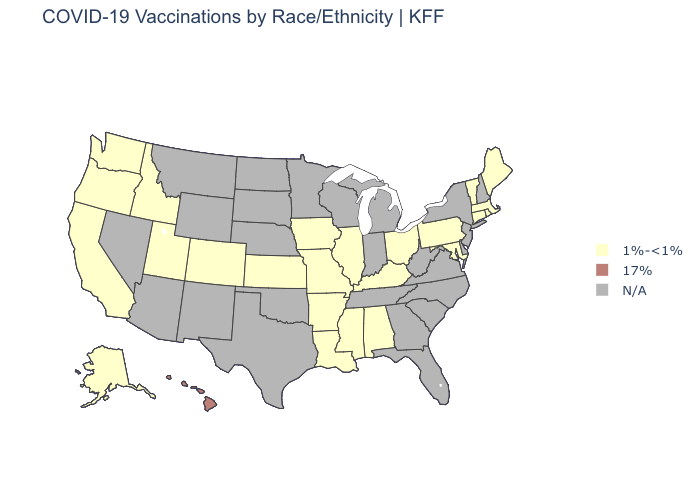Among the states that border Florida , which have the highest value?
Be succinct. Alabama. Is the legend a continuous bar?
Short answer required. No. Name the states that have a value in the range N/A?
Concise answer only. Arizona, Delaware, Florida, Georgia, Indiana, Michigan, Minnesota, Montana, Nebraska, Nevada, New Hampshire, New Jersey, New Mexico, New York, North Carolina, North Dakota, Oklahoma, South Carolina, South Dakota, Tennessee, Texas, Virginia, West Virginia, Wisconsin, Wyoming. Name the states that have a value in the range N/A?
Keep it brief. Arizona, Delaware, Florida, Georgia, Indiana, Michigan, Minnesota, Montana, Nebraska, Nevada, New Hampshire, New Jersey, New Mexico, New York, North Carolina, North Dakota, Oklahoma, South Carolina, South Dakota, Tennessee, Texas, Virginia, West Virginia, Wisconsin, Wyoming. Which states have the lowest value in the USA?
Give a very brief answer. Alabama, Alaska, Arkansas, California, Colorado, Connecticut, Idaho, Illinois, Iowa, Kansas, Kentucky, Louisiana, Maine, Maryland, Massachusetts, Mississippi, Missouri, Ohio, Oregon, Pennsylvania, Rhode Island, Utah, Vermont, Washington. What is the value of Mississippi?
Quick response, please. 1%-<1%. Does Hawaii have the lowest value in the West?
Write a very short answer. No. What is the value of New Jersey?
Keep it brief. N/A. What is the value of Washington?
Give a very brief answer. 1%-<1%. What is the value of Mississippi?
Concise answer only. 1%-<1%. Name the states that have a value in the range 1%-<1%?
Write a very short answer. Alabama, Alaska, Arkansas, California, Colorado, Connecticut, Idaho, Illinois, Iowa, Kansas, Kentucky, Louisiana, Maine, Maryland, Massachusetts, Mississippi, Missouri, Ohio, Oregon, Pennsylvania, Rhode Island, Utah, Vermont, Washington. 